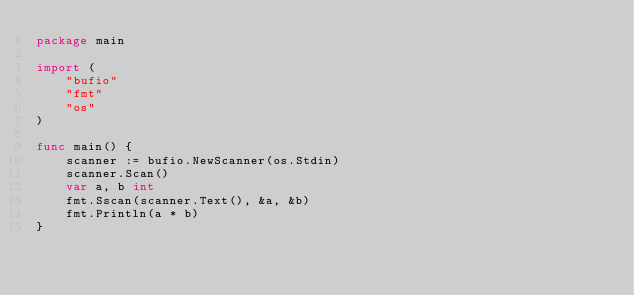Convert code to text. <code><loc_0><loc_0><loc_500><loc_500><_Go_>package main

import (
	"bufio"
	"fmt"
	"os"
)

func main() {
	scanner := bufio.NewScanner(os.Stdin)
	scanner.Scan()
	var a, b int
	fmt.Sscan(scanner.Text(), &a, &b)
	fmt.Println(a * b)
}
</code> 